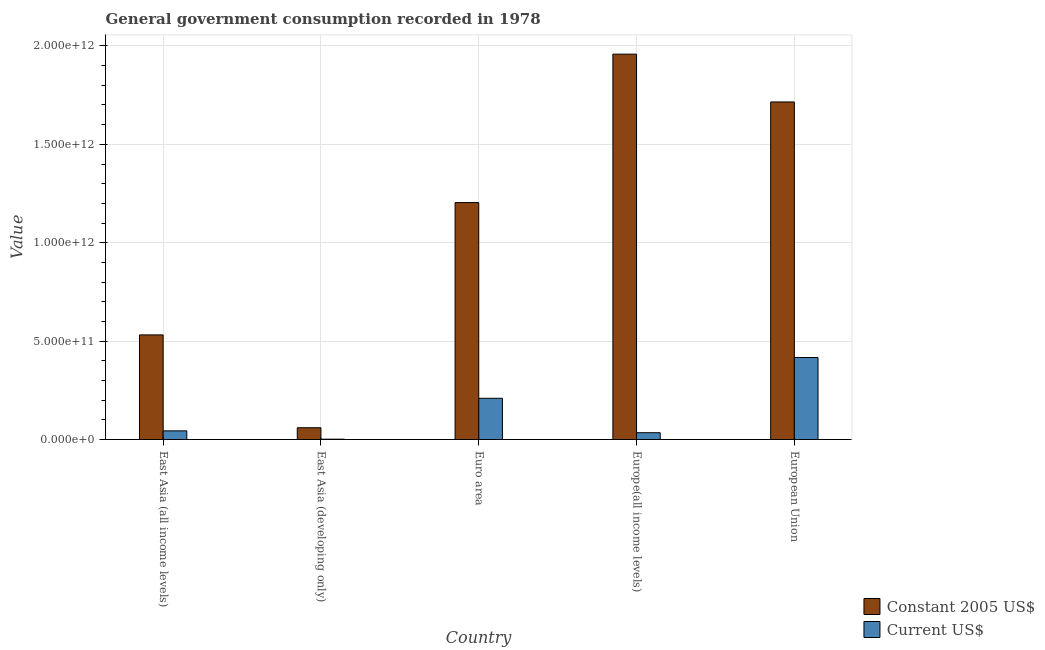How many different coloured bars are there?
Ensure brevity in your answer.  2. How many groups of bars are there?
Your answer should be very brief. 5. Are the number of bars per tick equal to the number of legend labels?
Offer a terse response. Yes. What is the value consumed in constant 2005 us$ in Europe(all income levels)?
Give a very brief answer. 1.96e+12. Across all countries, what is the maximum value consumed in constant 2005 us$?
Provide a short and direct response. 1.96e+12. Across all countries, what is the minimum value consumed in constant 2005 us$?
Provide a succinct answer. 5.98e+1. In which country was the value consumed in current us$ minimum?
Your answer should be compact. East Asia (developing only). What is the total value consumed in constant 2005 us$ in the graph?
Ensure brevity in your answer.  5.47e+12. What is the difference between the value consumed in current us$ in Euro area and that in European Union?
Offer a very short reply. -2.07e+11. What is the difference between the value consumed in current us$ in Euro area and the value consumed in constant 2005 us$ in East Asia (all income levels)?
Provide a succinct answer. -3.22e+11. What is the average value consumed in current us$ per country?
Provide a short and direct response. 1.41e+11. What is the difference between the value consumed in constant 2005 us$ and value consumed in current us$ in Euro area?
Your response must be concise. 9.95e+11. In how many countries, is the value consumed in constant 2005 us$ greater than 600000000000 ?
Offer a very short reply. 3. What is the ratio of the value consumed in current us$ in East Asia (developing only) to that in Euro area?
Your answer should be very brief. 0.01. What is the difference between the highest and the second highest value consumed in constant 2005 us$?
Your answer should be very brief. 2.43e+11. What is the difference between the highest and the lowest value consumed in constant 2005 us$?
Your answer should be very brief. 1.90e+12. In how many countries, is the value consumed in current us$ greater than the average value consumed in current us$ taken over all countries?
Offer a terse response. 2. Is the sum of the value consumed in current us$ in Euro area and European Union greater than the maximum value consumed in constant 2005 us$ across all countries?
Offer a very short reply. No. What does the 1st bar from the left in East Asia (all income levels) represents?
Keep it short and to the point. Constant 2005 US$. What does the 2nd bar from the right in Europe(all income levels) represents?
Your response must be concise. Constant 2005 US$. Are all the bars in the graph horizontal?
Give a very brief answer. No. What is the difference between two consecutive major ticks on the Y-axis?
Make the answer very short. 5.00e+11. Does the graph contain any zero values?
Give a very brief answer. No. Does the graph contain grids?
Keep it short and to the point. Yes. Where does the legend appear in the graph?
Offer a terse response. Bottom right. What is the title of the graph?
Give a very brief answer. General government consumption recorded in 1978. Does "Goods" appear as one of the legend labels in the graph?
Give a very brief answer. No. What is the label or title of the X-axis?
Offer a very short reply. Country. What is the label or title of the Y-axis?
Ensure brevity in your answer.  Value. What is the Value of Constant 2005 US$ in East Asia (all income levels)?
Make the answer very short. 5.32e+11. What is the Value of Current US$ in East Asia (all income levels)?
Offer a very short reply. 4.40e+1. What is the Value in Constant 2005 US$ in East Asia (developing only)?
Your answer should be very brief. 5.98e+1. What is the Value in Current US$ in East Asia (developing only)?
Your response must be concise. 1.76e+09. What is the Value of Constant 2005 US$ in Euro area?
Provide a short and direct response. 1.20e+12. What is the Value in Current US$ in Euro area?
Give a very brief answer. 2.10e+11. What is the Value of Constant 2005 US$ in Europe(all income levels)?
Your answer should be very brief. 1.96e+12. What is the Value in Current US$ in Europe(all income levels)?
Your answer should be compact. 3.46e+1. What is the Value in Constant 2005 US$ in European Union?
Your answer should be compact. 1.72e+12. What is the Value in Current US$ in European Union?
Your response must be concise. 4.17e+11. Across all countries, what is the maximum Value in Constant 2005 US$?
Keep it short and to the point. 1.96e+12. Across all countries, what is the maximum Value in Current US$?
Your answer should be very brief. 4.17e+11. Across all countries, what is the minimum Value of Constant 2005 US$?
Ensure brevity in your answer.  5.98e+1. Across all countries, what is the minimum Value of Current US$?
Your answer should be compact. 1.76e+09. What is the total Value in Constant 2005 US$ in the graph?
Give a very brief answer. 5.47e+12. What is the total Value in Current US$ in the graph?
Your response must be concise. 7.07e+11. What is the difference between the Value in Constant 2005 US$ in East Asia (all income levels) and that in East Asia (developing only)?
Provide a short and direct response. 4.72e+11. What is the difference between the Value of Current US$ in East Asia (all income levels) and that in East Asia (developing only)?
Provide a short and direct response. 4.23e+1. What is the difference between the Value of Constant 2005 US$ in East Asia (all income levels) and that in Euro area?
Offer a very short reply. -6.72e+11. What is the difference between the Value in Current US$ in East Asia (all income levels) and that in Euro area?
Provide a succinct answer. -1.65e+11. What is the difference between the Value in Constant 2005 US$ in East Asia (all income levels) and that in Europe(all income levels)?
Your answer should be very brief. -1.43e+12. What is the difference between the Value of Current US$ in East Asia (all income levels) and that in Europe(all income levels)?
Your answer should be very brief. 9.43e+09. What is the difference between the Value of Constant 2005 US$ in East Asia (all income levels) and that in European Union?
Offer a terse response. -1.18e+12. What is the difference between the Value in Current US$ in East Asia (all income levels) and that in European Union?
Offer a very short reply. -3.73e+11. What is the difference between the Value in Constant 2005 US$ in East Asia (developing only) and that in Euro area?
Your answer should be very brief. -1.14e+12. What is the difference between the Value of Current US$ in East Asia (developing only) and that in Euro area?
Offer a terse response. -2.08e+11. What is the difference between the Value in Constant 2005 US$ in East Asia (developing only) and that in Europe(all income levels)?
Give a very brief answer. -1.90e+12. What is the difference between the Value of Current US$ in East Asia (developing only) and that in Europe(all income levels)?
Ensure brevity in your answer.  -3.28e+1. What is the difference between the Value in Constant 2005 US$ in East Asia (developing only) and that in European Union?
Keep it short and to the point. -1.66e+12. What is the difference between the Value of Current US$ in East Asia (developing only) and that in European Union?
Keep it short and to the point. -4.15e+11. What is the difference between the Value in Constant 2005 US$ in Euro area and that in Europe(all income levels)?
Ensure brevity in your answer.  -7.54e+11. What is the difference between the Value in Current US$ in Euro area and that in Europe(all income levels)?
Your answer should be compact. 1.75e+11. What is the difference between the Value of Constant 2005 US$ in Euro area and that in European Union?
Provide a short and direct response. -5.11e+11. What is the difference between the Value in Current US$ in Euro area and that in European Union?
Provide a short and direct response. -2.07e+11. What is the difference between the Value of Constant 2005 US$ in Europe(all income levels) and that in European Union?
Provide a succinct answer. 2.43e+11. What is the difference between the Value of Current US$ in Europe(all income levels) and that in European Union?
Provide a succinct answer. -3.82e+11. What is the difference between the Value in Constant 2005 US$ in East Asia (all income levels) and the Value in Current US$ in East Asia (developing only)?
Offer a terse response. 5.30e+11. What is the difference between the Value of Constant 2005 US$ in East Asia (all income levels) and the Value of Current US$ in Euro area?
Your answer should be very brief. 3.22e+11. What is the difference between the Value of Constant 2005 US$ in East Asia (all income levels) and the Value of Current US$ in Europe(all income levels)?
Your answer should be compact. 4.97e+11. What is the difference between the Value of Constant 2005 US$ in East Asia (all income levels) and the Value of Current US$ in European Union?
Make the answer very short. 1.15e+11. What is the difference between the Value of Constant 2005 US$ in East Asia (developing only) and the Value of Current US$ in Euro area?
Your response must be concise. -1.50e+11. What is the difference between the Value in Constant 2005 US$ in East Asia (developing only) and the Value in Current US$ in Europe(all income levels)?
Make the answer very short. 2.52e+1. What is the difference between the Value of Constant 2005 US$ in East Asia (developing only) and the Value of Current US$ in European Union?
Your answer should be compact. -3.57e+11. What is the difference between the Value of Constant 2005 US$ in Euro area and the Value of Current US$ in Europe(all income levels)?
Your response must be concise. 1.17e+12. What is the difference between the Value of Constant 2005 US$ in Euro area and the Value of Current US$ in European Union?
Your response must be concise. 7.87e+11. What is the difference between the Value in Constant 2005 US$ in Europe(all income levels) and the Value in Current US$ in European Union?
Your answer should be very brief. 1.54e+12. What is the average Value in Constant 2005 US$ per country?
Offer a very short reply. 1.09e+12. What is the average Value of Current US$ per country?
Offer a terse response. 1.41e+11. What is the difference between the Value in Constant 2005 US$ and Value in Current US$ in East Asia (all income levels)?
Your answer should be very brief. 4.88e+11. What is the difference between the Value of Constant 2005 US$ and Value of Current US$ in East Asia (developing only)?
Your answer should be compact. 5.81e+1. What is the difference between the Value in Constant 2005 US$ and Value in Current US$ in Euro area?
Your response must be concise. 9.95e+11. What is the difference between the Value in Constant 2005 US$ and Value in Current US$ in Europe(all income levels)?
Your answer should be very brief. 1.92e+12. What is the difference between the Value of Constant 2005 US$ and Value of Current US$ in European Union?
Offer a terse response. 1.30e+12. What is the ratio of the Value in Constant 2005 US$ in East Asia (all income levels) to that in East Asia (developing only)?
Keep it short and to the point. 8.89. What is the ratio of the Value in Current US$ in East Asia (all income levels) to that in East Asia (developing only)?
Make the answer very short. 25.03. What is the ratio of the Value of Constant 2005 US$ in East Asia (all income levels) to that in Euro area?
Give a very brief answer. 0.44. What is the ratio of the Value of Current US$ in East Asia (all income levels) to that in Euro area?
Provide a succinct answer. 0.21. What is the ratio of the Value of Constant 2005 US$ in East Asia (all income levels) to that in Europe(all income levels)?
Ensure brevity in your answer.  0.27. What is the ratio of the Value of Current US$ in East Asia (all income levels) to that in Europe(all income levels)?
Your response must be concise. 1.27. What is the ratio of the Value in Constant 2005 US$ in East Asia (all income levels) to that in European Union?
Give a very brief answer. 0.31. What is the ratio of the Value in Current US$ in East Asia (all income levels) to that in European Union?
Your answer should be compact. 0.11. What is the ratio of the Value of Constant 2005 US$ in East Asia (developing only) to that in Euro area?
Offer a terse response. 0.05. What is the ratio of the Value of Current US$ in East Asia (developing only) to that in Euro area?
Offer a terse response. 0.01. What is the ratio of the Value of Constant 2005 US$ in East Asia (developing only) to that in Europe(all income levels)?
Provide a short and direct response. 0.03. What is the ratio of the Value of Current US$ in East Asia (developing only) to that in Europe(all income levels)?
Offer a terse response. 0.05. What is the ratio of the Value of Constant 2005 US$ in East Asia (developing only) to that in European Union?
Keep it short and to the point. 0.03. What is the ratio of the Value in Current US$ in East Asia (developing only) to that in European Union?
Your answer should be very brief. 0. What is the ratio of the Value in Constant 2005 US$ in Euro area to that in Europe(all income levels)?
Provide a succinct answer. 0.61. What is the ratio of the Value of Current US$ in Euro area to that in Europe(all income levels)?
Offer a terse response. 6.06. What is the ratio of the Value in Constant 2005 US$ in Euro area to that in European Union?
Offer a very short reply. 0.7. What is the ratio of the Value of Current US$ in Euro area to that in European Union?
Your answer should be compact. 0.5. What is the ratio of the Value of Constant 2005 US$ in Europe(all income levels) to that in European Union?
Your answer should be very brief. 1.14. What is the ratio of the Value of Current US$ in Europe(all income levels) to that in European Union?
Make the answer very short. 0.08. What is the difference between the highest and the second highest Value in Constant 2005 US$?
Your answer should be compact. 2.43e+11. What is the difference between the highest and the second highest Value in Current US$?
Keep it short and to the point. 2.07e+11. What is the difference between the highest and the lowest Value of Constant 2005 US$?
Give a very brief answer. 1.90e+12. What is the difference between the highest and the lowest Value of Current US$?
Make the answer very short. 4.15e+11. 